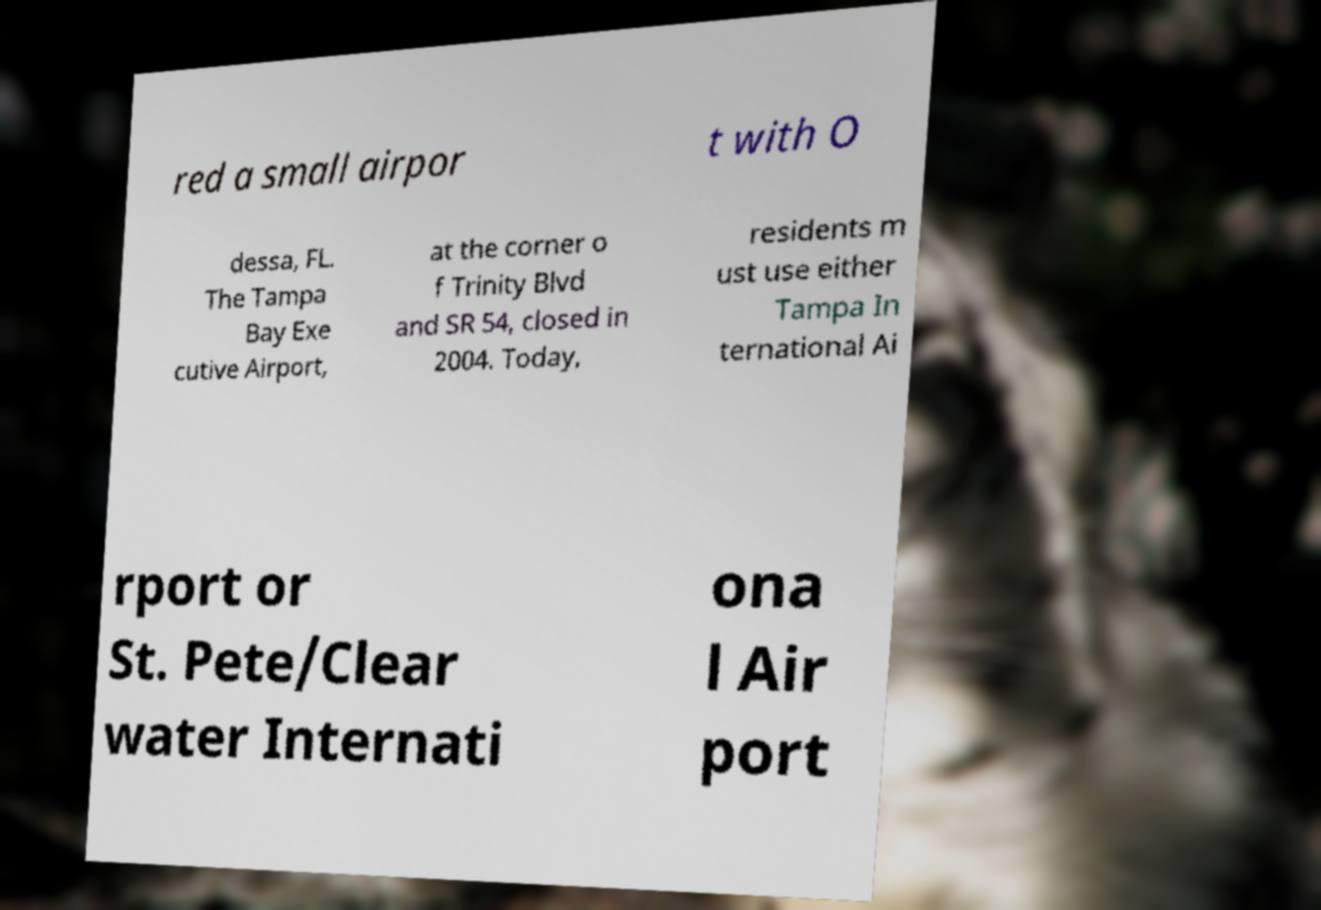Please identify and transcribe the text found in this image. red a small airpor t with O dessa, FL. The Tampa Bay Exe cutive Airport, at the corner o f Trinity Blvd and SR 54, closed in 2004. Today, residents m ust use either Tampa In ternational Ai rport or St. Pete/Clear water Internati ona l Air port 